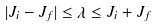<formula> <loc_0><loc_0><loc_500><loc_500>| J _ { i } - J _ { f } | \leq \lambda \leq J _ { i } + J _ { f }</formula> 